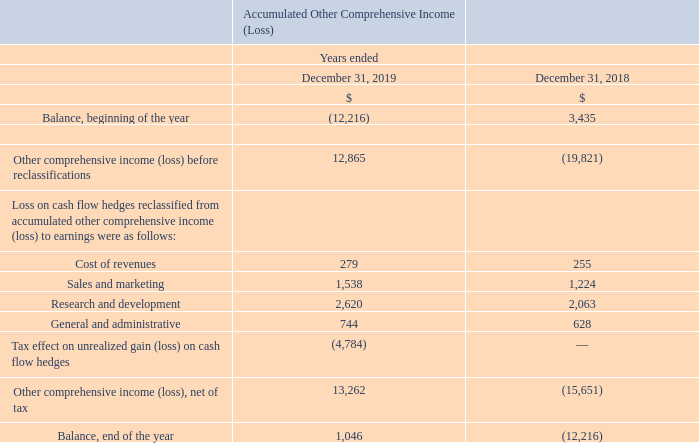Changes in Accumulated Other Comprehensive Income (Loss)
The following table summarizes the changes in accumulated other comprehensive income (loss), which is reported as a component of shareholders’ equity, for the years ended December 31, 2019 and 2018:
Expressed in US $000's except share and per share amounts
What information does the table show? The changes in accumulated other comprehensive income (loss), which is reported as a component of shareholders’ equity, for the years ended december 31, 2019 and 2018:. What is the accumulated other comprehensive income at the beginning of 2019?
Answer scale should be: thousand. (12,216). What is the accumulated other comprehensive income at the beginning of 2018?
Answer scale should be: thousand. 3,435. What is the average ending balance of accumulated other comprehensive income for 2018 and 2019?
Answer scale should be: thousand. [1,046 + (-12,216)] /2
Answer: -5585. What is the average reclassification of cost of revenues for 2018 and 2019?
Answer scale should be: thousand. (279+255)/2
Answer: 267. What is the average reclassification of sales and marketing for 2018 and 2019?
Answer scale should be: thousand. (1,538+1,224)/2
Answer: 1381. 